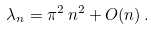<formula> <loc_0><loc_0><loc_500><loc_500>\lambda _ { n } = \pi ^ { 2 } \, n ^ { 2 } + O ( n ) \, .</formula> 